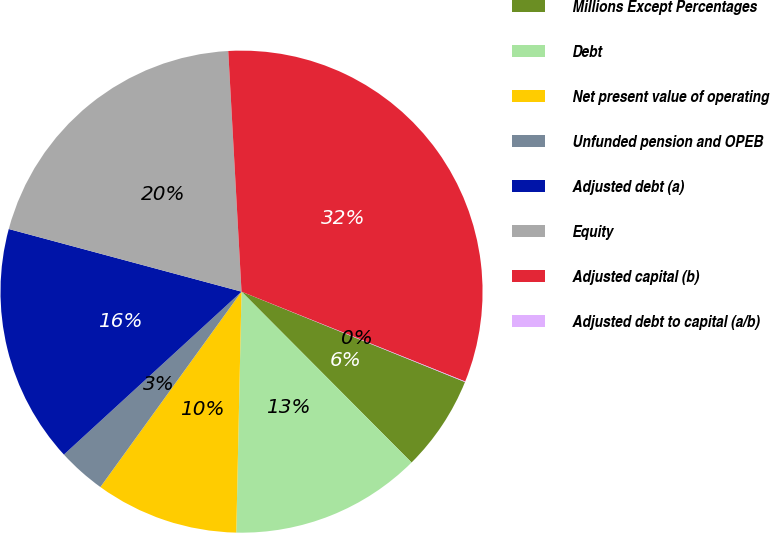Convert chart to OTSL. <chart><loc_0><loc_0><loc_500><loc_500><pie_chart><fcel>Millions Except Percentages<fcel>Debt<fcel>Net present value of operating<fcel>Unfunded pension and OPEB<fcel>Adjusted debt (a)<fcel>Equity<fcel>Adjusted capital (b)<fcel>Adjusted debt to capital (a/b)<nl><fcel>6.42%<fcel>12.81%<fcel>9.61%<fcel>3.23%<fcel>16.0%<fcel>19.94%<fcel>31.96%<fcel>0.04%<nl></chart> 